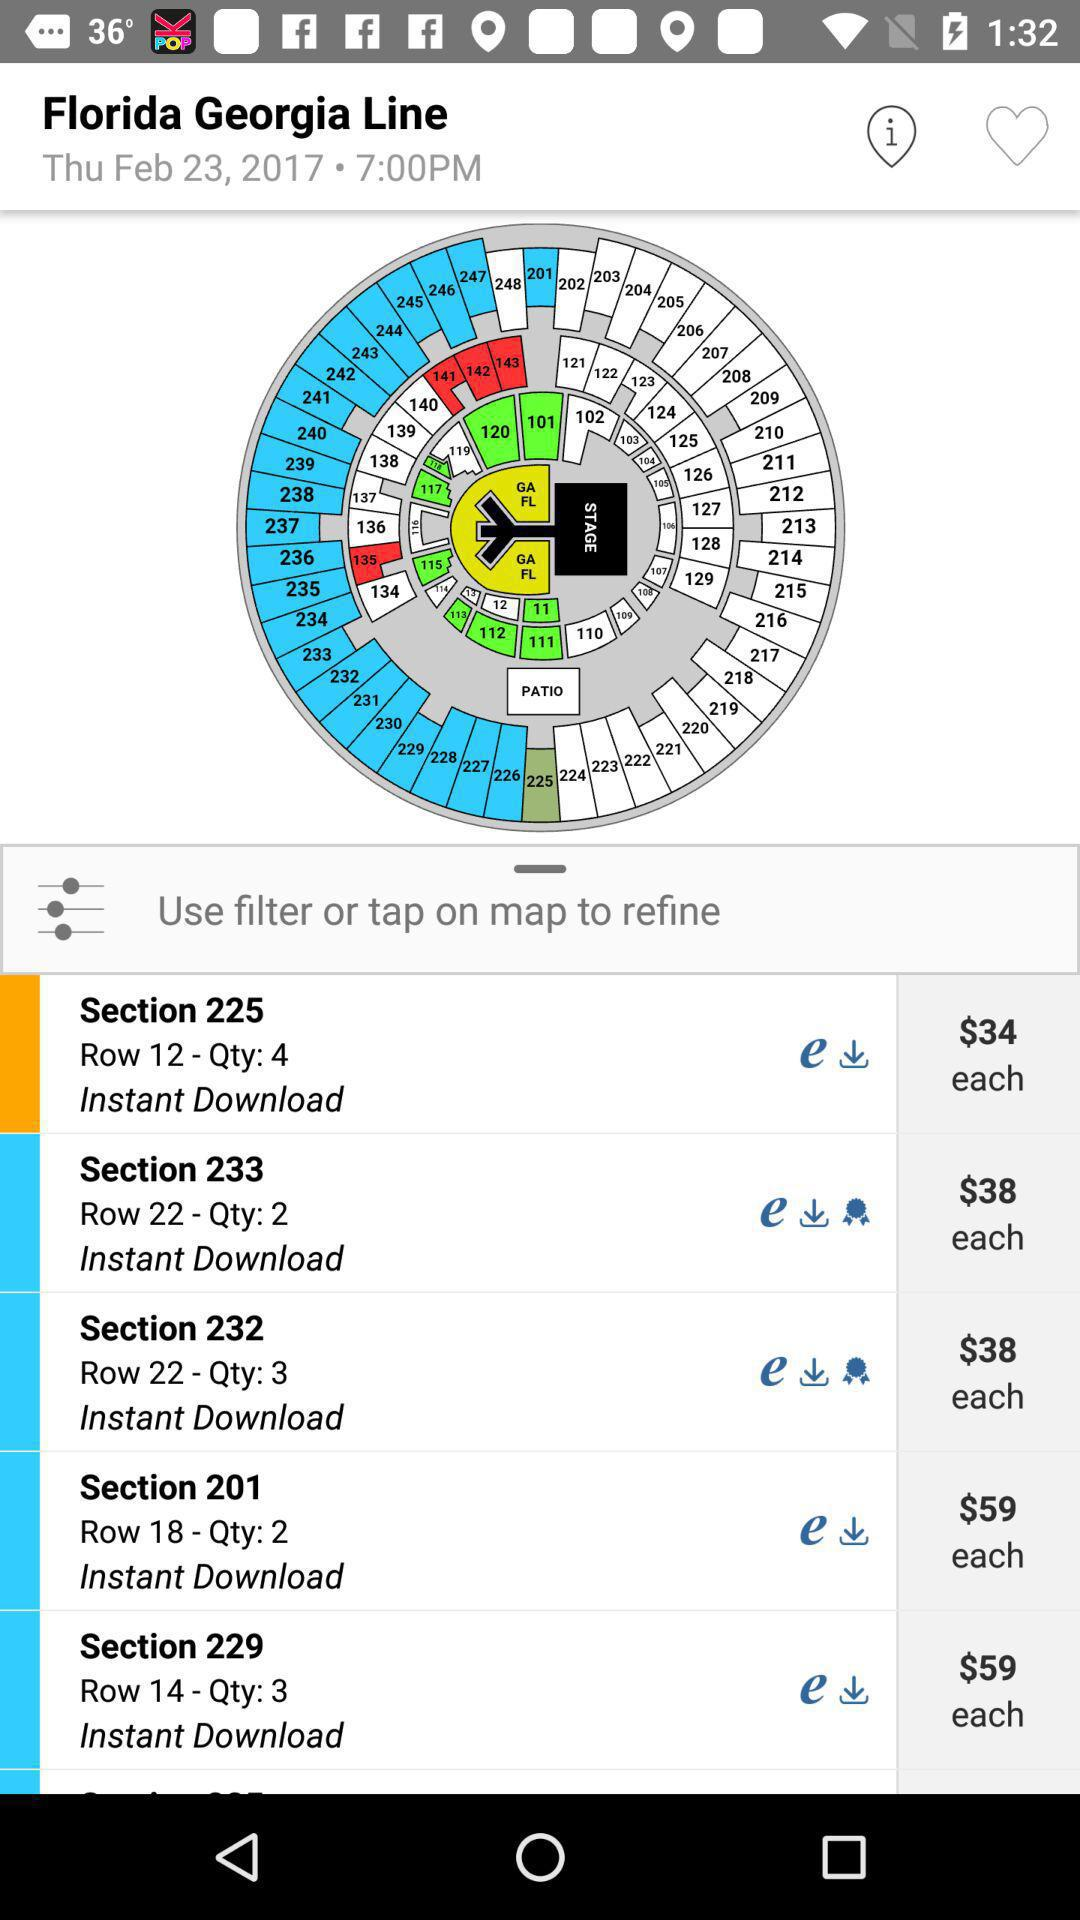What day is it on February 23? The day is Thursday. 